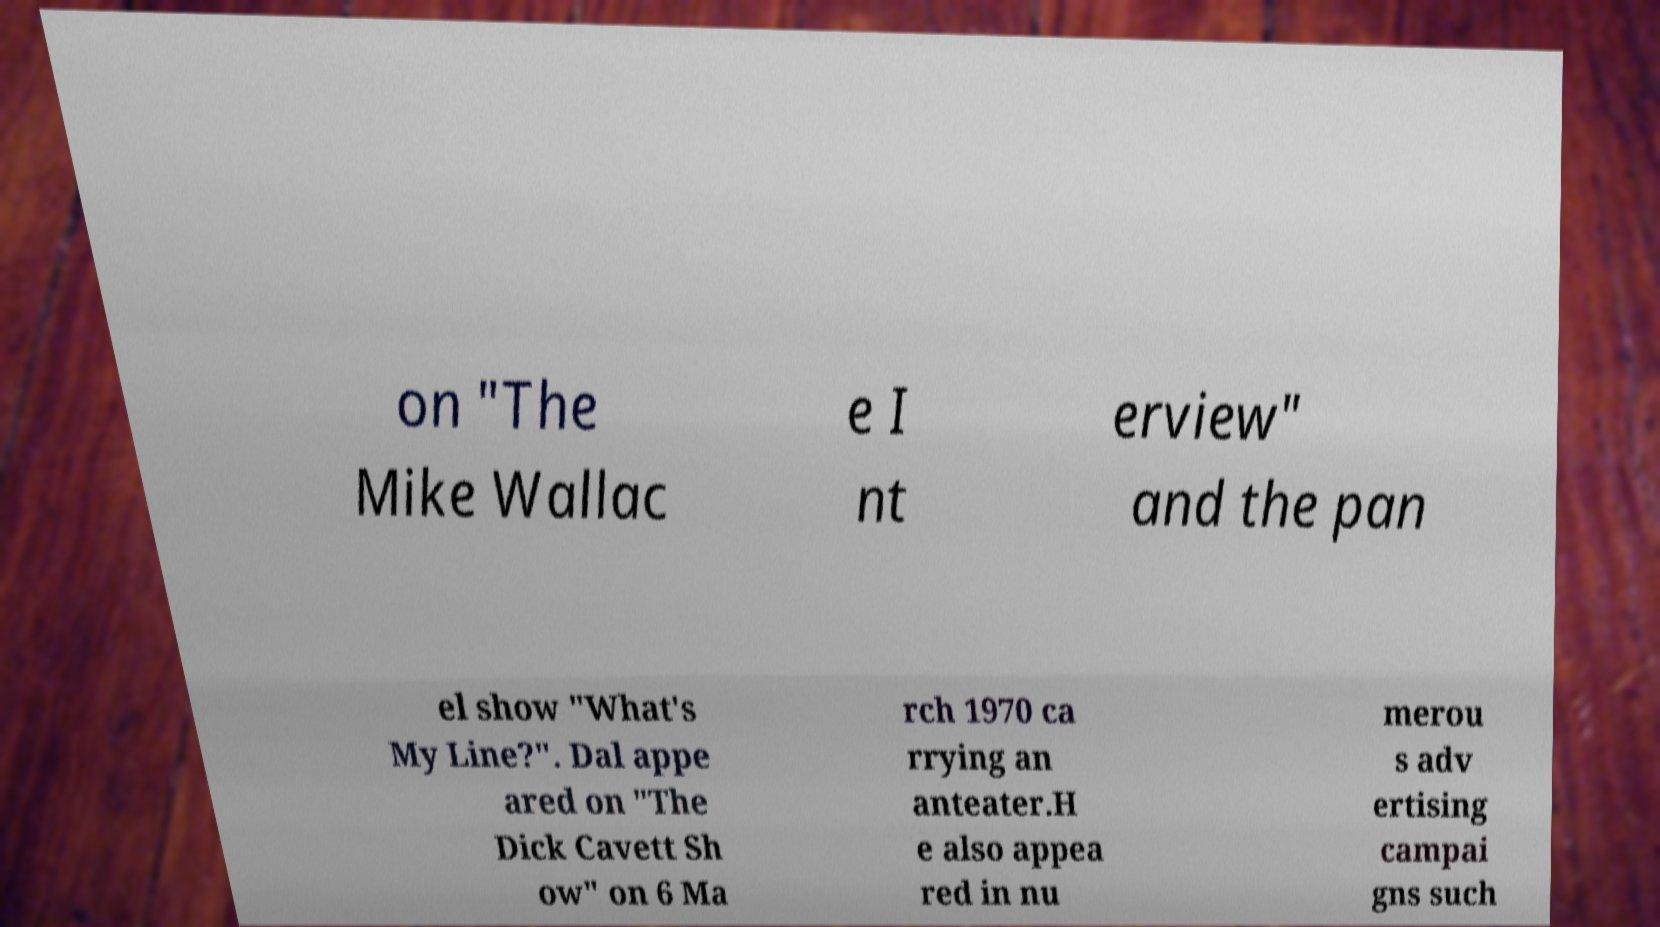For documentation purposes, I need the text within this image transcribed. Could you provide that? on "The Mike Wallac e I nt erview" and the pan el show "What's My Line?". Dal appe ared on "The Dick Cavett Sh ow" on 6 Ma rch 1970 ca rrying an anteater.H e also appea red in nu merou s adv ertising campai gns such 